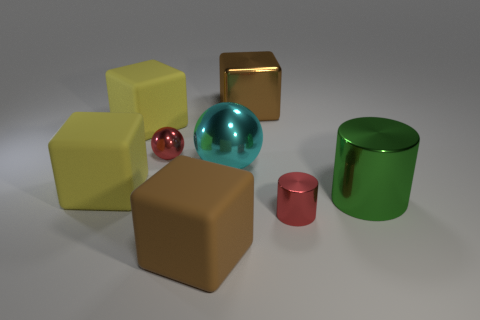There is a brown cube that is in front of the small red cylinder; is there a small cylinder that is on the left side of it?
Your response must be concise. No. Are any big metal spheres visible?
Ensure brevity in your answer.  Yes. How many cyan things have the same size as the cyan ball?
Your answer should be compact. 0. What number of metal things are both to the right of the big metallic block and behind the small red cylinder?
Provide a short and direct response. 1. Does the brown object behind the green thing have the same size as the small red shiny sphere?
Offer a very short reply. No. Are there any other small metallic spheres that have the same color as the tiny shiny ball?
Your response must be concise. No. What is the size of the other cylinder that is the same material as the small red cylinder?
Offer a terse response. Large. Are there more cyan balls that are behind the large metal block than big blocks to the left of the large sphere?
Your answer should be compact. No. How many other things are there of the same material as the big green object?
Ensure brevity in your answer.  4. Is the material of the tiny red object that is in front of the big metal sphere the same as the cyan thing?
Offer a very short reply. Yes. 